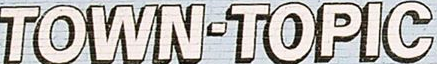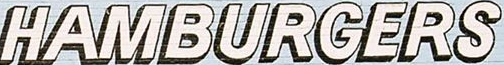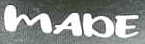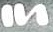Read the text content from these images in order, separated by a semicolon. TOWN-TOPIC; HAMBURGERS; MADE; In 